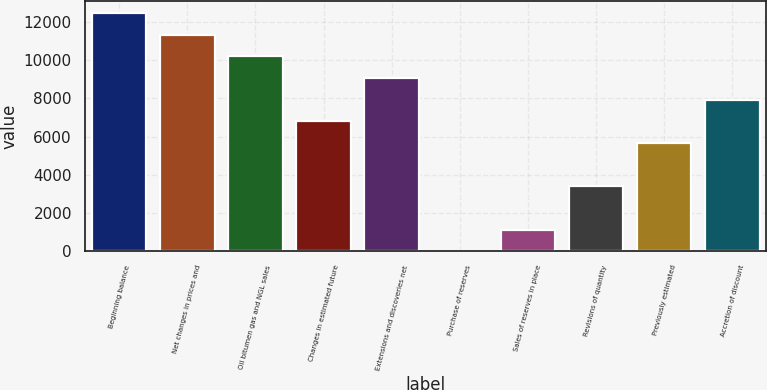<chart> <loc_0><loc_0><loc_500><loc_500><bar_chart><fcel>Beginning balance<fcel>Net changes in prices and<fcel>Oil bitumen gas and NGL sales<fcel>Changes in estimated future<fcel>Extensions and discoveries net<fcel>Purchase of reserves<fcel>Sales of reserves in place<fcel>Revisions of quantity<fcel>Previously estimated<fcel>Accretion of discount<nl><fcel>12470.5<fcel>11337<fcel>10203.5<fcel>6803<fcel>9070<fcel>2<fcel>1135.5<fcel>3402.5<fcel>5669.5<fcel>7936.5<nl></chart> 